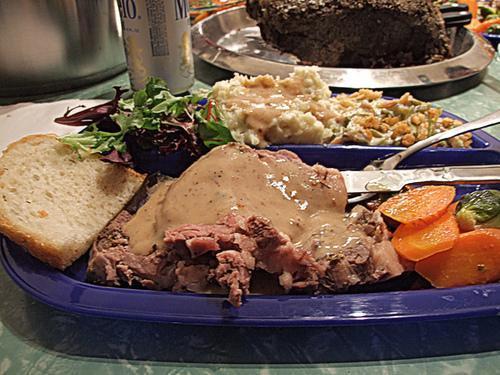How many carrots are visible?
Give a very brief answer. 3. 